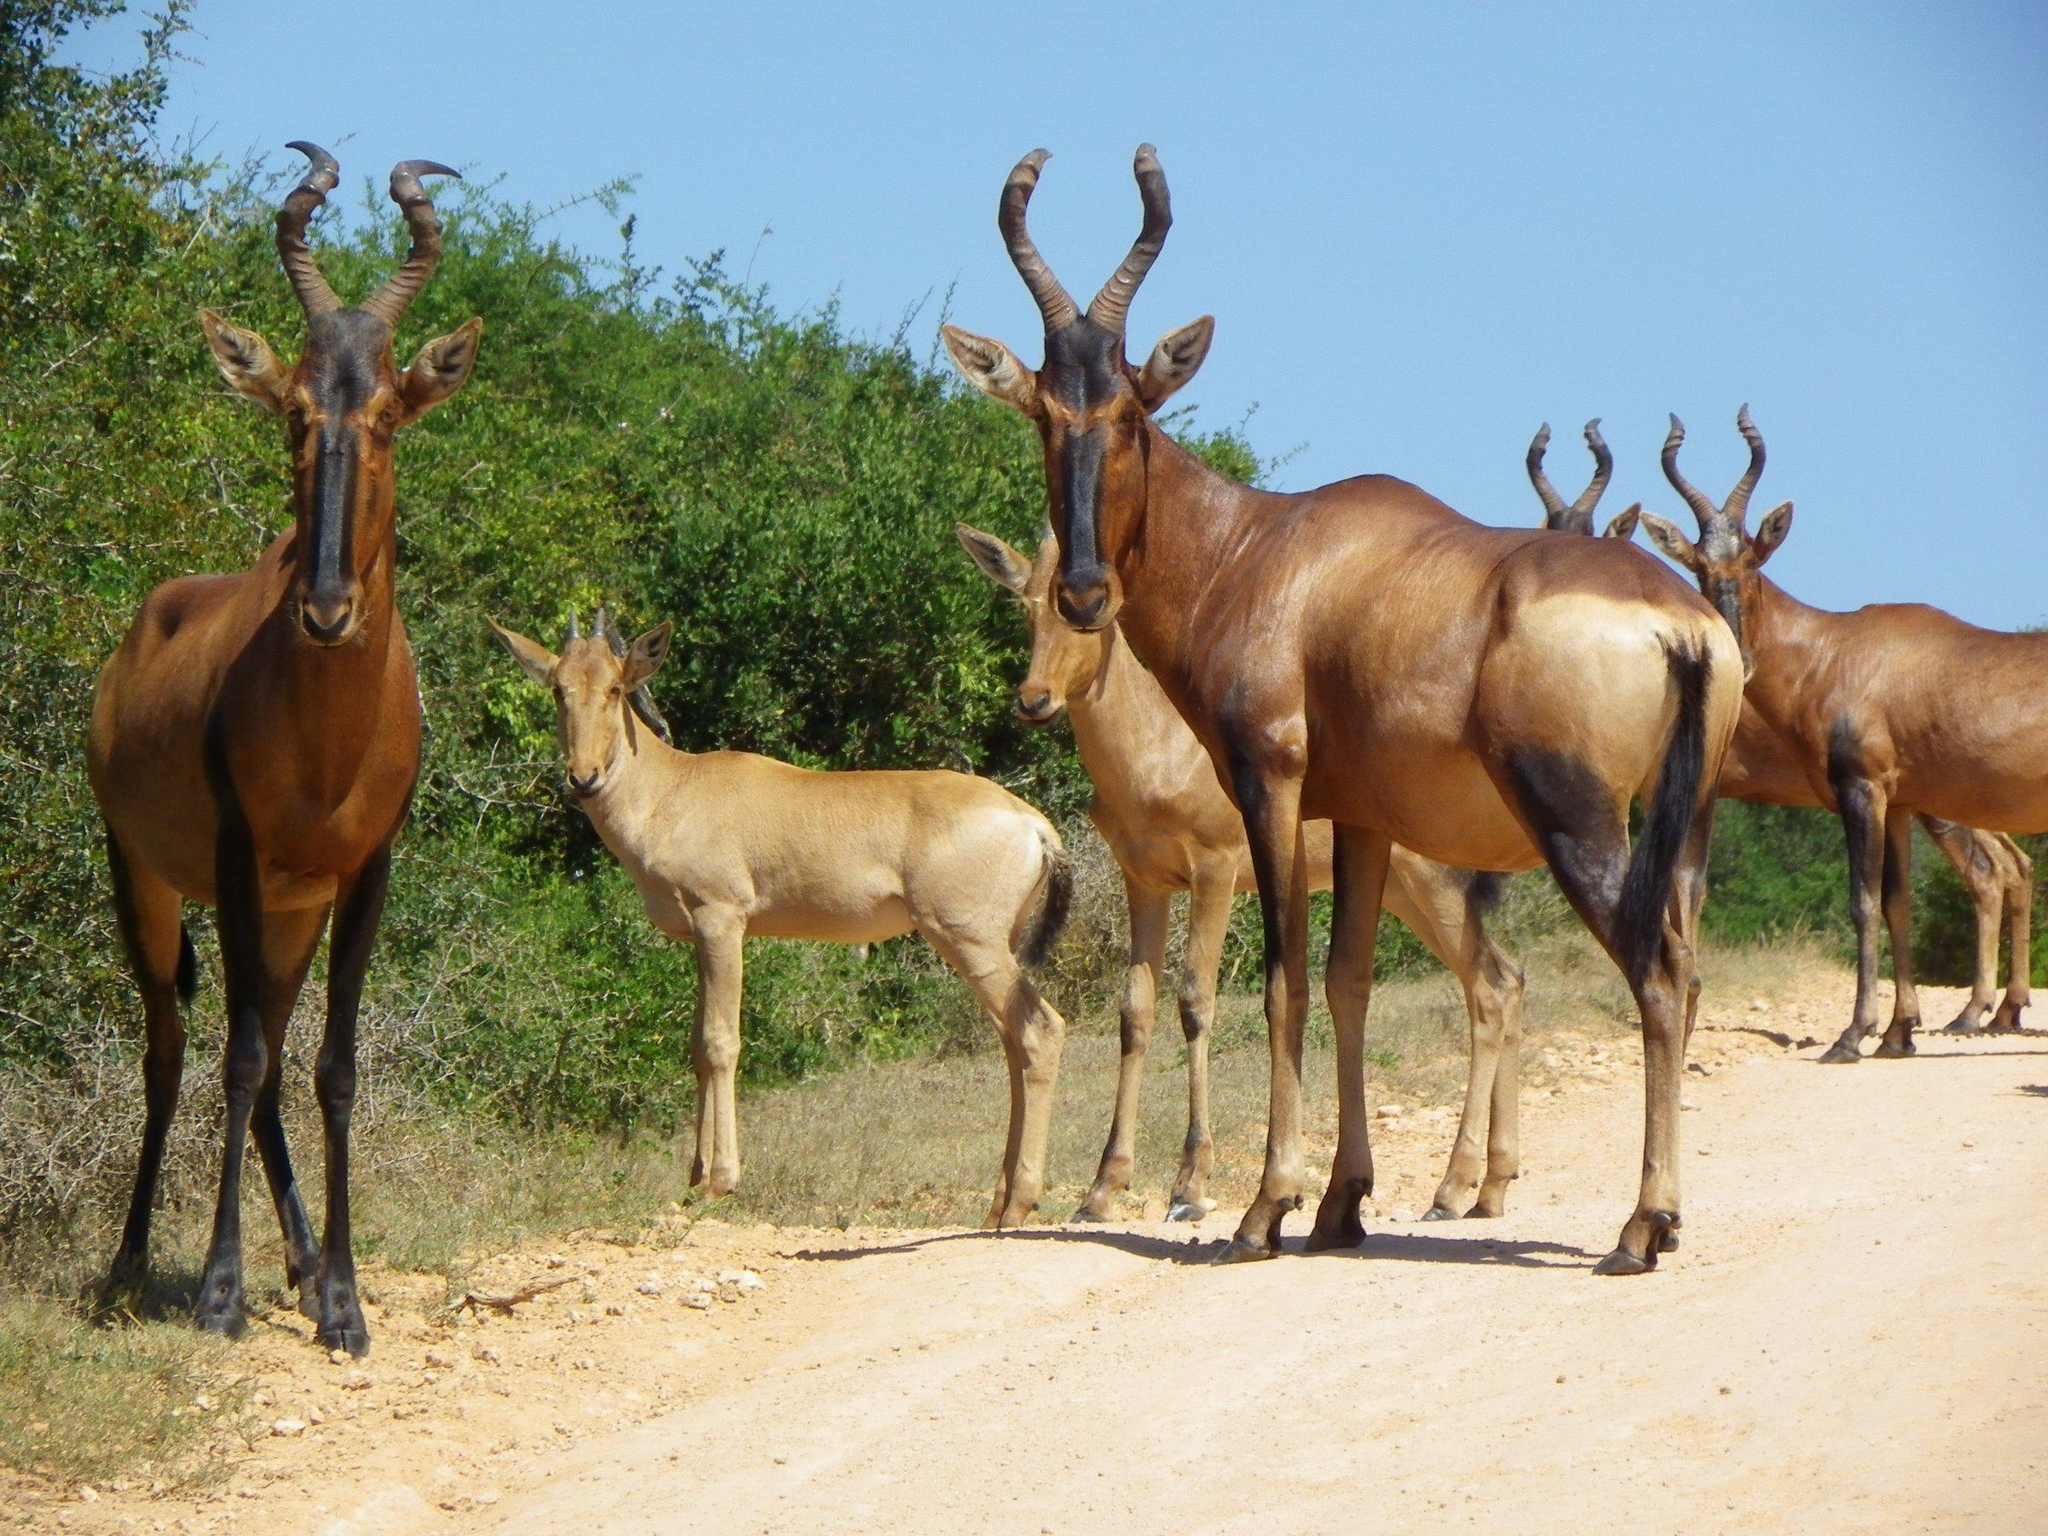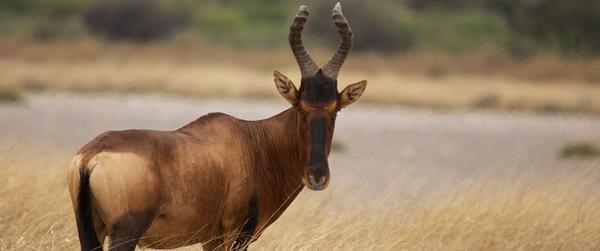The first image is the image on the left, the second image is the image on the right. For the images shown, is this caption "Lefthand image contains two horned animals standing in a field." true? Answer yes or no. No. The first image is the image on the left, the second image is the image on the right. Assess this claim about the two images: "One of the images shows exactly two antelopes that are standing.". Correct or not? Answer yes or no. No. 